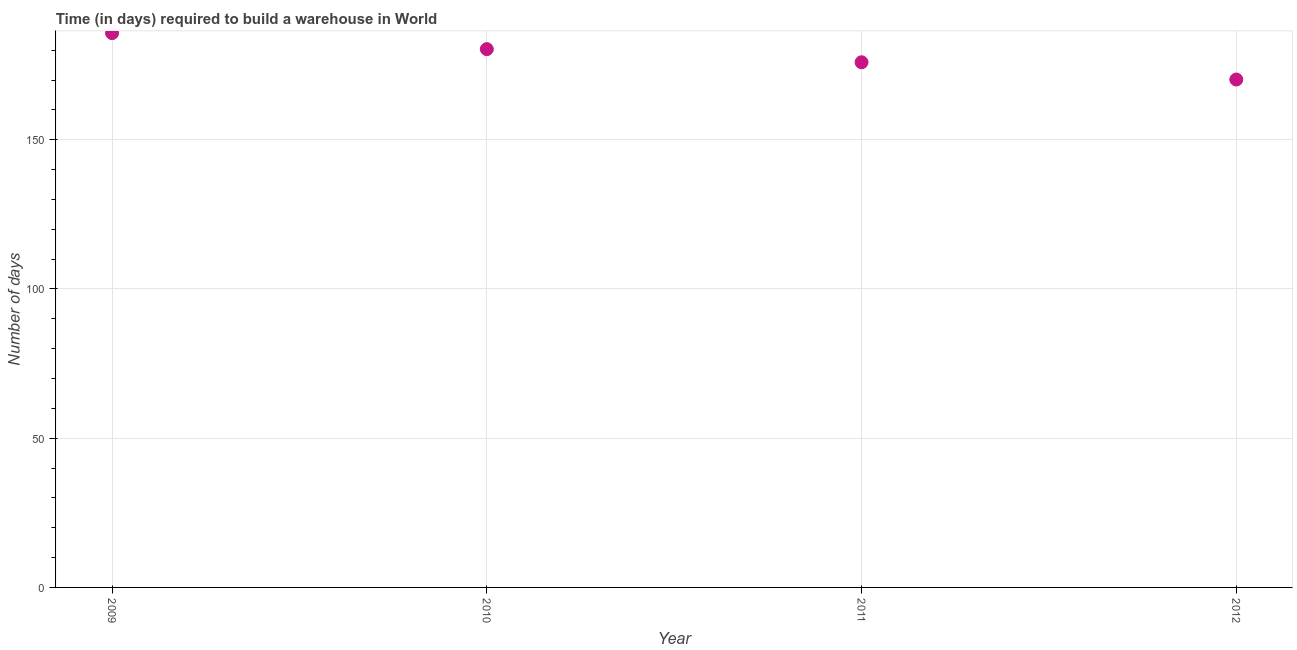What is the time required to build a warehouse in 2009?
Provide a succinct answer. 185.71. Across all years, what is the maximum time required to build a warehouse?
Provide a short and direct response. 185.71. Across all years, what is the minimum time required to build a warehouse?
Keep it short and to the point. 170.18. In which year was the time required to build a warehouse minimum?
Your answer should be very brief. 2012. What is the sum of the time required to build a warehouse?
Provide a short and direct response. 712.2. What is the difference between the time required to build a warehouse in 2009 and 2010?
Give a very brief answer. 5.36. What is the average time required to build a warehouse per year?
Offer a terse response. 178.05. What is the median time required to build a warehouse?
Your response must be concise. 178.16. Do a majority of the years between 2009 and 2010 (inclusive) have time required to build a warehouse greater than 100 days?
Keep it short and to the point. Yes. What is the ratio of the time required to build a warehouse in 2009 to that in 2010?
Your answer should be very brief. 1.03. Is the time required to build a warehouse in 2010 less than that in 2011?
Provide a short and direct response. No. Is the difference between the time required to build a warehouse in 2010 and 2011 greater than the difference between any two years?
Make the answer very short. No. What is the difference between the highest and the second highest time required to build a warehouse?
Make the answer very short. 5.36. What is the difference between the highest and the lowest time required to build a warehouse?
Offer a very short reply. 15.54. Does the time required to build a warehouse monotonically increase over the years?
Your answer should be very brief. No. How many years are there in the graph?
Your response must be concise. 4. What is the difference between two consecutive major ticks on the Y-axis?
Your answer should be very brief. 50. Are the values on the major ticks of Y-axis written in scientific E-notation?
Offer a terse response. No. Does the graph contain any zero values?
Offer a very short reply. No. Does the graph contain grids?
Provide a short and direct response. Yes. What is the title of the graph?
Provide a short and direct response. Time (in days) required to build a warehouse in World. What is the label or title of the Y-axis?
Your answer should be very brief. Number of days. What is the Number of days in 2009?
Give a very brief answer. 185.71. What is the Number of days in 2010?
Keep it short and to the point. 180.35. What is the Number of days in 2011?
Make the answer very short. 175.96. What is the Number of days in 2012?
Ensure brevity in your answer.  170.18. What is the difference between the Number of days in 2009 and 2010?
Provide a short and direct response. 5.36. What is the difference between the Number of days in 2009 and 2011?
Your answer should be compact. 9.76. What is the difference between the Number of days in 2009 and 2012?
Your answer should be compact. 15.54. What is the difference between the Number of days in 2010 and 2011?
Keep it short and to the point. 4.4. What is the difference between the Number of days in 2010 and 2012?
Provide a succinct answer. 10.18. What is the difference between the Number of days in 2011 and 2012?
Your response must be concise. 5.78. What is the ratio of the Number of days in 2009 to that in 2010?
Provide a short and direct response. 1.03. What is the ratio of the Number of days in 2009 to that in 2011?
Keep it short and to the point. 1.05. What is the ratio of the Number of days in 2009 to that in 2012?
Give a very brief answer. 1.09. What is the ratio of the Number of days in 2010 to that in 2012?
Your response must be concise. 1.06. What is the ratio of the Number of days in 2011 to that in 2012?
Your answer should be very brief. 1.03. 